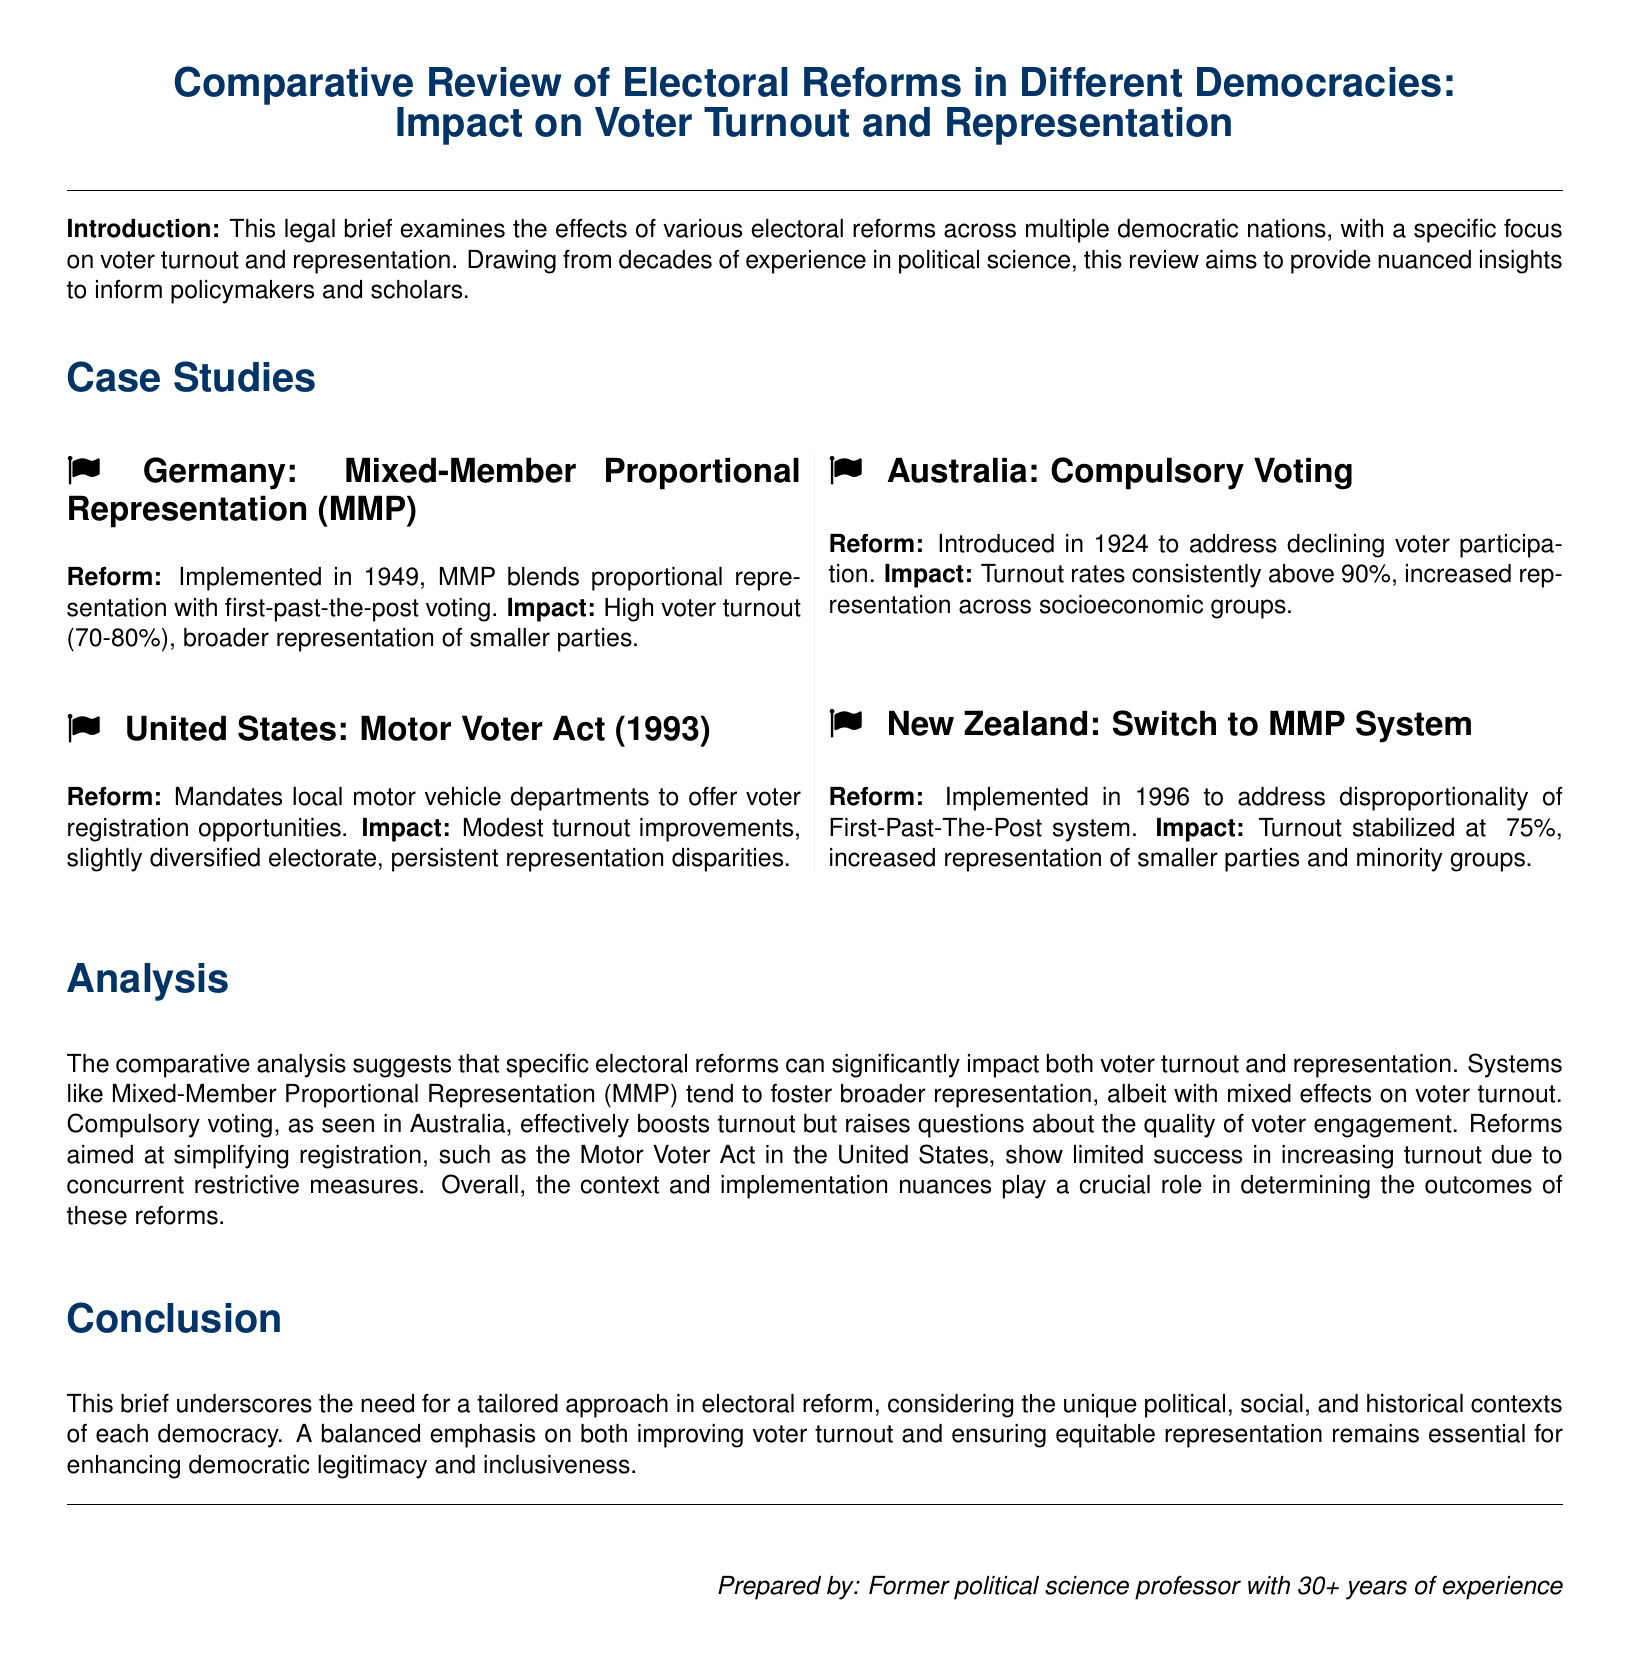What electoral reform was implemented in Germany in 1949? The document states that Germany implemented the Mixed-Member Proportional Representation (MMP) reform in 1949.
Answer: Mixed-Member Proportional Representation (MMP) What is the typical voter turnout percentage in Australia due to compulsory voting? The document mentions that Australia's turnout rates are consistently above 90% due to compulsory voting.
Answer: above 90% What impact did the Motor Voter Act have on the electorate in the United States? According to the document, the impact was that it slightly diversified the electorate.
Answer: slightly diversified electorate When was New Zealand's switch to the MMP system implemented? The document indicates that New Zealand switched to the MMP system in 1996.
Answer: 1996 What is the primary focus of the legal brief? The brief examines the effects of various electoral reforms on voter turnout and representation across multiple democratic nations.
Answer: voter turnout and representation Which electoral reform is associated with high voter turnout but questions about voter engagement quality? The document states that compulsory voting in Australia is associated with these characteristics.
Answer: compulsory voting What is a significant finding regarding electoral reforms and their impact on representation? The analysis in the document suggests that specific reforms can significantly impact representation, particularly MMP systems.
Answer: significant impact on representation What does the conclusion emphasize regarding electoral reforms? The conclusion underscores the need for a tailored approach considering unique political and social contexts.
Answer: tailored approach 